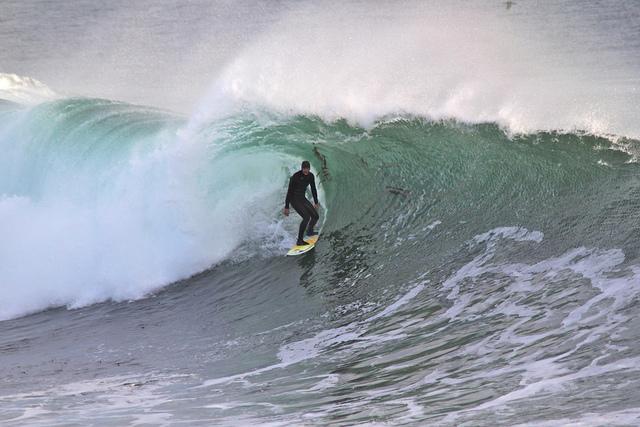What color is the surfboard?
Keep it brief. Yellow. Where in the wave is the man?
Answer briefly. Under it. What is the suit that the man is wearing called?
Give a very brief answer. Wetsuit. 